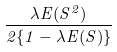<formula> <loc_0><loc_0><loc_500><loc_500>\frac { \lambda E ( S ^ { 2 } ) } { 2 \{ 1 - \lambda E ( S ) \} }</formula> 